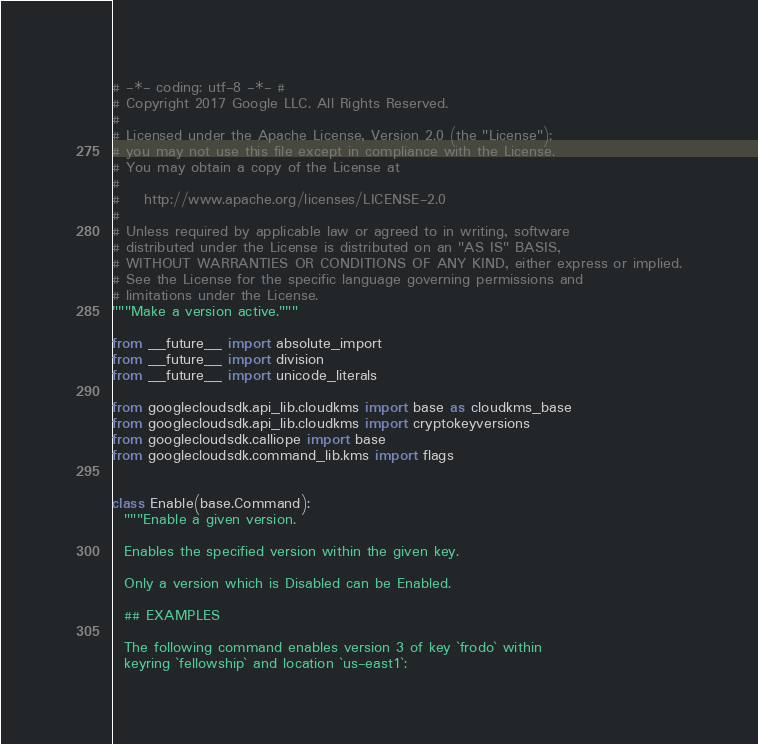Convert code to text. <code><loc_0><loc_0><loc_500><loc_500><_Python_># -*- coding: utf-8 -*- #
# Copyright 2017 Google LLC. All Rights Reserved.
#
# Licensed under the Apache License, Version 2.0 (the "License");
# you may not use this file except in compliance with the License.
# You may obtain a copy of the License at
#
#    http://www.apache.org/licenses/LICENSE-2.0
#
# Unless required by applicable law or agreed to in writing, software
# distributed under the License is distributed on an "AS IS" BASIS,
# WITHOUT WARRANTIES OR CONDITIONS OF ANY KIND, either express or implied.
# See the License for the specific language governing permissions and
# limitations under the License.
"""Make a version active."""

from __future__ import absolute_import
from __future__ import division
from __future__ import unicode_literals

from googlecloudsdk.api_lib.cloudkms import base as cloudkms_base
from googlecloudsdk.api_lib.cloudkms import cryptokeyversions
from googlecloudsdk.calliope import base
from googlecloudsdk.command_lib.kms import flags


class Enable(base.Command):
  """Enable a given version.

  Enables the specified version within the given key.

  Only a version which is Disabled can be Enabled.

  ## EXAMPLES

  The following command enables version 3 of key `frodo` within
  keyring `fellowship` and location `us-east1`:
</code> 